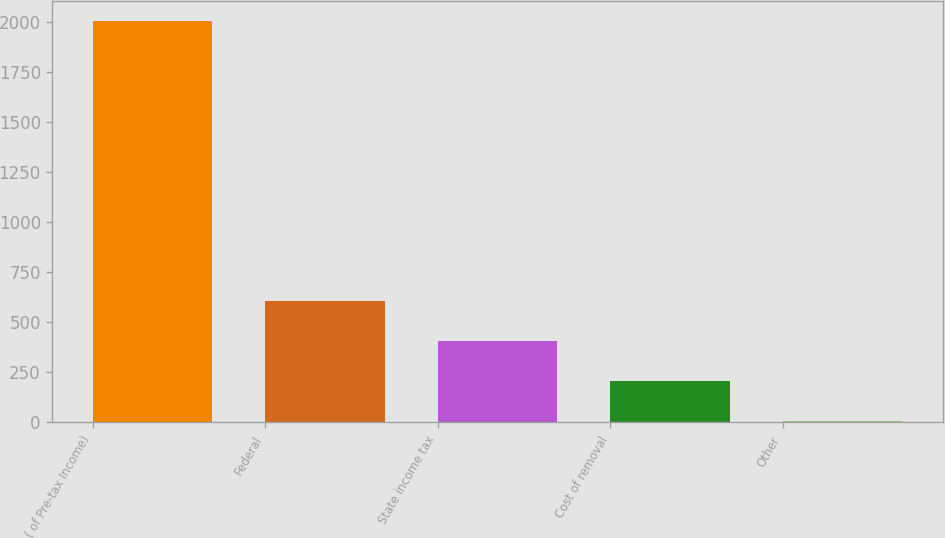<chart> <loc_0><loc_0><loc_500><loc_500><bar_chart><fcel>( of Pre-tax Income)<fcel>Federal<fcel>State income tax<fcel>Cost of removal<fcel>Other<nl><fcel>2002<fcel>603.4<fcel>403.6<fcel>203.8<fcel>4<nl></chart> 